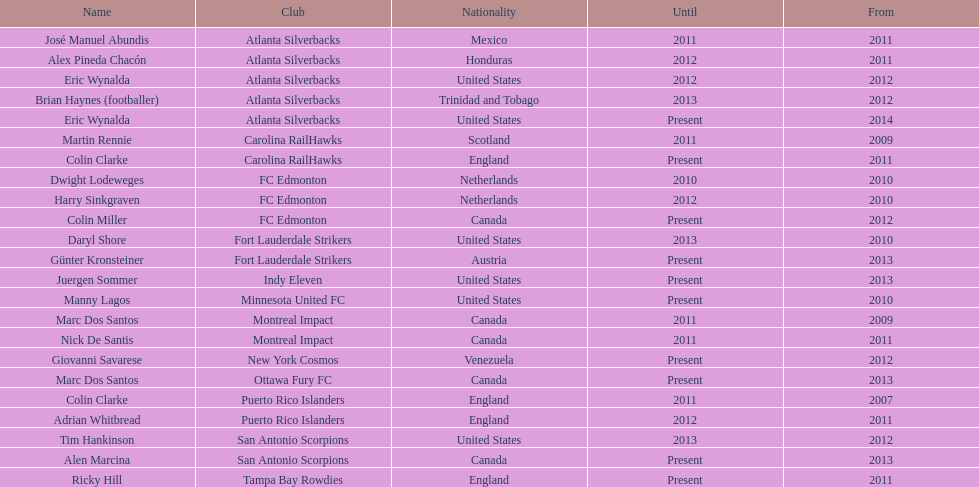Could you parse the entire table? {'header': ['Name', 'Club', 'Nationality', 'Until', 'From'], 'rows': [['José Manuel Abundis', 'Atlanta Silverbacks', 'Mexico', '2011', '2011'], ['Alex Pineda Chacón', 'Atlanta Silverbacks', 'Honduras', '2012', '2011'], ['Eric Wynalda', 'Atlanta Silverbacks', 'United States', '2012', '2012'], ['Brian Haynes (footballer)', 'Atlanta Silverbacks', 'Trinidad and Tobago', '2013', '2012'], ['Eric Wynalda', 'Atlanta Silverbacks', 'United States', 'Present', '2014'], ['Martin Rennie', 'Carolina RailHawks', 'Scotland', '2011', '2009'], ['Colin Clarke', 'Carolina RailHawks', 'England', 'Present', '2011'], ['Dwight Lodeweges', 'FC Edmonton', 'Netherlands', '2010', '2010'], ['Harry Sinkgraven', 'FC Edmonton', 'Netherlands', '2012', '2010'], ['Colin Miller', 'FC Edmonton', 'Canada', 'Present', '2012'], ['Daryl Shore', 'Fort Lauderdale Strikers', 'United States', '2013', '2010'], ['Günter Kronsteiner', 'Fort Lauderdale Strikers', 'Austria', 'Present', '2013'], ['Juergen Sommer', 'Indy Eleven', 'United States', 'Present', '2013'], ['Manny Lagos', 'Minnesota United FC', 'United States', 'Present', '2010'], ['Marc Dos Santos', 'Montreal Impact', 'Canada', '2011', '2009'], ['Nick De Santis', 'Montreal Impact', 'Canada', '2011', '2011'], ['Giovanni Savarese', 'New York Cosmos', 'Venezuela', 'Present', '2012'], ['Marc Dos Santos', 'Ottawa Fury FC', 'Canada', 'Present', '2013'], ['Colin Clarke', 'Puerto Rico Islanders', 'England', '2011', '2007'], ['Adrian Whitbread', 'Puerto Rico Islanders', 'England', '2012', '2011'], ['Tim Hankinson', 'San Antonio Scorpions', 'United States', '2013', '2012'], ['Alen Marcina', 'San Antonio Scorpions', 'Canada', 'Present', '2013'], ['Ricky Hill', 'Tampa Bay Rowdies', 'England', 'Present', '2011']]} How many total coaches on the list are from canada? 5. 